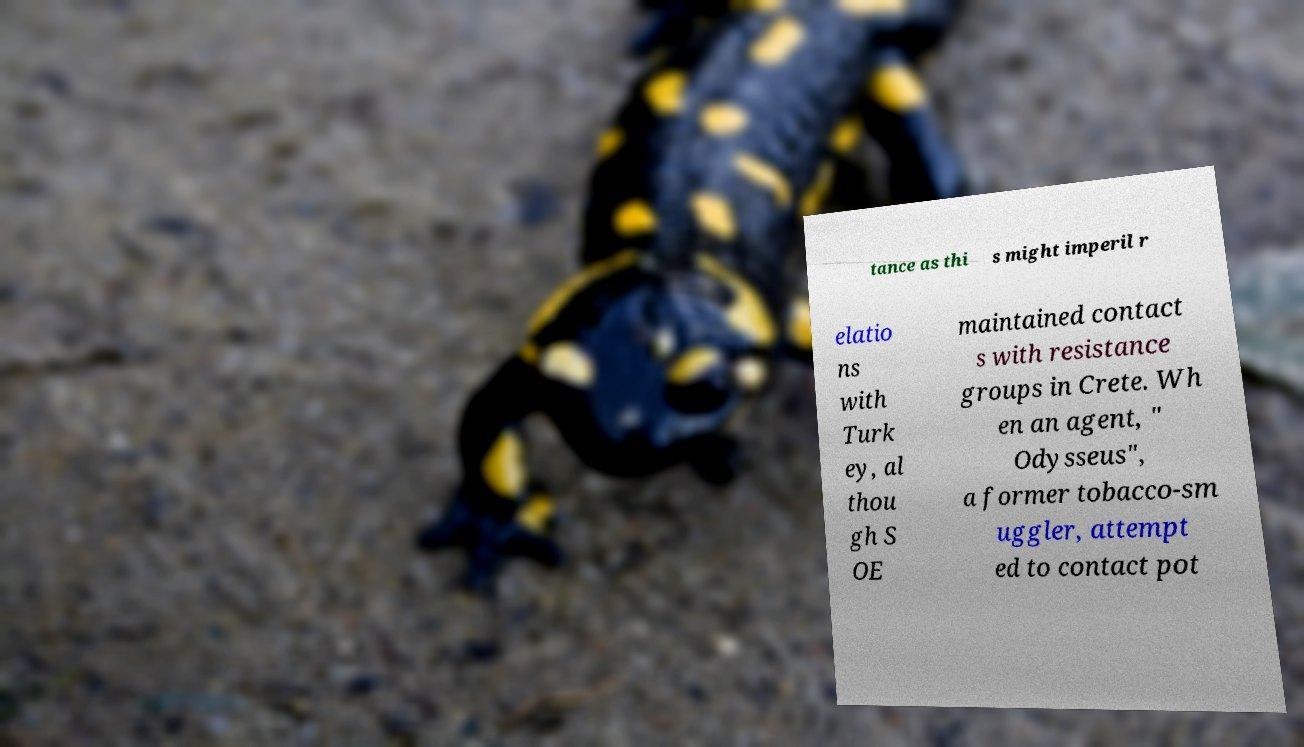I need the written content from this picture converted into text. Can you do that? tance as thi s might imperil r elatio ns with Turk ey, al thou gh S OE maintained contact s with resistance groups in Crete. Wh en an agent, " Odysseus", a former tobacco-sm uggler, attempt ed to contact pot 